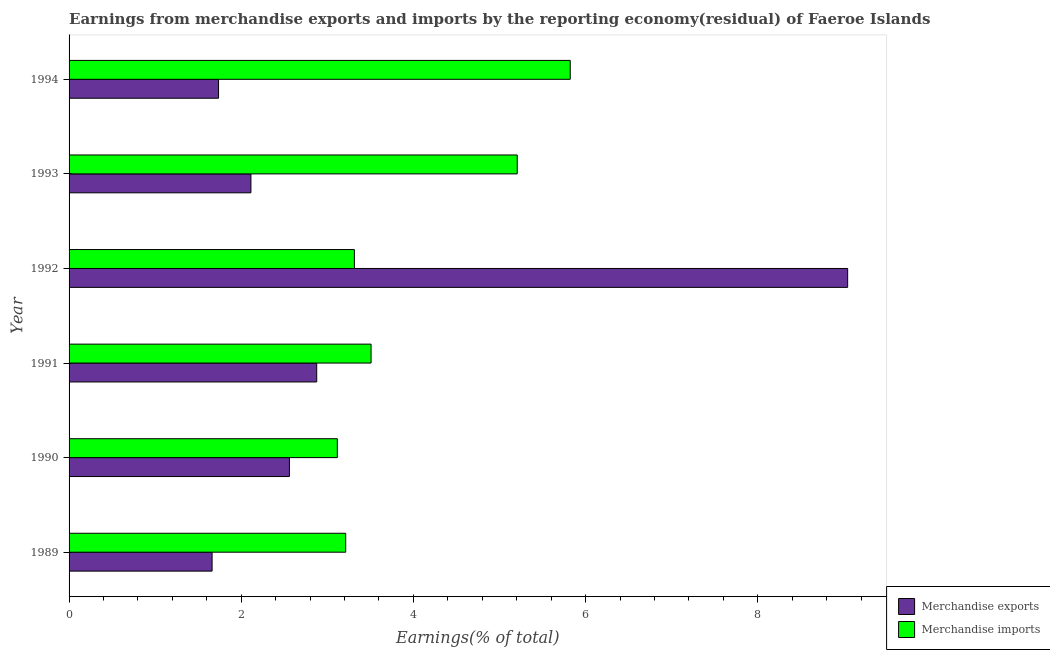How many groups of bars are there?
Offer a terse response. 6. Are the number of bars per tick equal to the number of legend labels?
Provide a short and direct response. Yes. How many bars are there on the 5th tick from the bottom?
Your answer should be very brief. 2. What is the label of the 4th group of bars from the top?
Offer a terse response. 1991. In how many cases, is the number of bars for a given year not equal to the number of legend labels?
Give a very brief answer. 0. What is the earnings from merchandise imports in 1990?
Your answer should be very brief. 3.12. Across all years, what is the maximum earnings from merchandise imports?
Give a very brief answer. 5.82. Across all years, what is the minimum earnings from merchandise imports?
Give a very brief answer. 3.12. In which year was the earnings from merchandise exports minimum?
Keep it short and to the point. 1989. What is the total earnings from merchandise exports in the graph?
Offer a terse response. 19.99. What is the difference between the earnings from merchandise exports in 1992 and that in 1993?
Make the answer very short. 6.93. What is the difference between the earnings from merchandise imports in 1992 and the earnings from merchandise exports in 1991?
Offer a very short reply. 0.44. What is the average earnings from merchandise imports per year?
Your answer should be very brief. 4.03. In the year 1991, what is the difference between the earnings from merchandise imports and earnings from merchandise exports?
Offer a very short reply. 0.63. In how many years, is the earnings from merchandise imports greater than 2.4 %?
Provide a short and direct response. 6. What is the ratio of the earnings from merchandise exports in 1989 to that in 1994?
Your answer should be very brief. 0.96. Is the earnings from merchandise exports in 1990 less than that in 1992?
Provide a succinct answer. Yes. Is the difference between the earnings from merchandise exports in 1990 and 1992 greater than the difference between the earnings from merchandise imports in 1990 and 1992?
Ensure brevity in your answer.  No. What is the difference between the highest and the second highest earnings from merchandise imports?
Offer a very short reply. 0.62. What is the difference between the highest and the lowest earnings from merchandise exports?
Offer a terse response. 7.38. In how many years, is the earnings from merchandise imports greater than the average earnings from merchandise imports taken over all years?
Offer a very short reply. 2. What does the 2nd bar from the top in 1991 represents?
Keep it short and to the point. Merchandise exports. What does the 1st bar from the bottom in 1994 represents?
Make the answer very short. Merchandise exports. Are all the bars in the graph horizontal?
Your response must be concise. Yes. How many years are there in the graph?
Keep it short and to the point. 6. What is the difference between two consecutive major ticks on the X-axis?
Your answer should be compact. 2. Are the values on the major ticks of X-axis written in scientific E-notation?
Your answer should be compact. No. Does the graph contain any zero values?
Make the answer very short. No. What is the title of the graph?
Your response must be concise. Earnings from merchandise exports and imports by the reporting economy(residual) of Faeroe Islands. Does "National Visitors" appear as one of the legend labels in the graph?
Provide a short and direct response. No. What is the label or title of the X-axis?
Give a very brief answer. Earnings(% of total). What is the Earnings(% of total) in Merchandise exports in 1989?
Ensure brevity in your answer.  1.66. What is the Earnings(% of total) in Merchandise imports in 1989?
Make the answer very short. 3.21. What is the Earnings(% of total) in Merchandise exports in 1990?
Provide a succinct answer. 2.56. What is the Earnings(% of total) of Merchandise imports in 1990?
Your response must be concise. 3.12. What is the Earnings(% of total) in Merchandise exports in 1991?
Your response must be concise. 2.88. What is the Earnings(% of total) in Merchandise imports in 1991?
Keep it short and to the point. 3.51. What is the Earnings(% of total) of Merchandise exports in 1992?
Make the answer very short. 9.04. What is the Earnings(% of total) in Merchandise imports in 1992?
Provide a succinct answer. 3.31. What is the Earnings(% of total) of Merchandise exports in 1993?
Keep it short and to the point. 2.11. What is the Earnings(% of total) in Merchandise imports in 1993?
Ensure brevity in your answer.  5.21. What is the Earnings(% of total) of Merchandise exports in 1994?
Keep it short and to the point. 1.74. What is the Earnings(% of total) of Merchandise imports in 1994?
Offer a terse response. 5.82. Across all years, what is the maximum Earnings(% of total) of Merchandise exports?
Provide a short and direct response. 9.04. Across all years, what is the maximum Earnings(% of total) of Merchandise imports?
Provide a succinct answer. 5.82. Across all years, what is the minimum Earnings(% of total) of Merchandise exports?
Keep it short and to the point. 1.66. Across all years, what is the minimum Earnings(% of total) of Merchandise imports?
Your response must be concise. 3.12. What is the total Earnings(% of total) of Merchandise exports in the graph?
Provide a short and direct response. 19.99. What is the total Earnings(% of total) of Merchandise imports in the graph?
Give a very brief answer. 24.18. What is the difference between the Earnings(% of total) in Merchandise exports in 1989 and that in 1990?
Give a very brief answer. -0.9. What is the difference between the Earnings(% of total) of Merchandise imports in 1989 and that in 1990?
Keep it short and to the point. 0.1. What is the difference between the Earnings(% of total) of Merchandise exports in 1989 and that in 1991?
Give a very brief answer. -1.22. What is the difference between the Earnings(% of total) of Merchandise imports in 1989 and that in 1991?
Your answer should be compact. -0.29. What is the difference between the Earnings(% of total) in Merchandise exports in 1989 and that in 1992?
Give a very brief answer. -7.38. What is the difference between the Earnings(% of total) in Merchandise imports in 1989 and that in 1992?
Your answer should be very brief. -0.1. What is the difference between the Earnings(% of total) of Merchandise exports in 1989 and that in 1993?
Make the answer very short. -0.45. What is the difference between the Earnings(% of total) in Merchandise imports in 1989 and that in 1993?
Provide a succinct answer. -1.99. What is the difference between the Earnings(% of total) of Merchandise exports in 1989 and that in 1994?
Your answer should be very brief. -0.07. What is the difference between the Earnings(% of total) of Merchandise imports in 1989 and that in 1994?
Provide a short and direct response. -2.61. What is the difference between the Earnings(% of total) of Merchandise exports in 1990 and that in 1991?
Offer a very short reply. -0.32. What is the difference between the Earnings(% of total) of Merchandise imports in 1990 and that in 1991?
Offer a terse response. -0.39. What is the difference between the Earnings(% of total) in Merchandise exports in 1990 and that in 1992?
Provide a succinct answer. -6.48. What is the difference between the Earnings(% of total) in Merchandise imports in 1990 and that in 1992?
Provide a short and direct response. -0.2. What is the difference between the Earnings(% of total) in Merchandise exports in 1990 and that in 1993?
Your answer should be compact. 0.45. What is the difference between the Earnings(% of total) of Merchandise imports in 1990 and that in 1993?
Ensure brevity in your answer.  -2.09. What is the difference between the Earnings(% of total) in Merchandise exports in 1990 and that in 1994?
Give a very brief answer. 0.82. What is the difference between the Earnings(% of total) in Merchandise imports in 1990 and that in 1994?
Provide a short and direct response. -2.71. What is the difference between the Earnings(% of total) of Merchandise exports in 1991 and that in 1992?
Ensure brevity in your answer.  -6.17. What is the difference between the Earnings(% of total) in Merchandise imports in 1991 and that in 1992?
Your response must be concise. 0.19. What is the difference between the Earnings(% of total) of Merchandise exports in 1991 and that in 1993?
Your response must be concise. 0.76. What is the difference between the Earnings(% of total) in Merchandise imports in 1991 and that in 1993?
Your answer should be very brief. -1.7. What is the difference between the Earnings(% of total) in Merchandise exports in 1991 and that in 1994?
Keep it short and to the point. 1.14. What is the difference between the Earnings(% of total) of Merchandise imports in 1991 and that in 1994?
Your answer should be very brief. -2.31. What is the difference between the Earnings(% of total) of Merchandise exports in 1992 and that in 1993?
Your answer should be compact. 6.93. What is the difference between the Earnings(% of total) of Merchandise imports in 1992 and that in 1993?
Make the answer very short. -1.89. What is the difference between the Earnings(% of total) in Merchandise exports in 1992 and that in 1994?
Give a very brief answer. 7.31. What is the difference between the Earnings(% of total) of Merchandise imports in 1992 and that in 1994?
Offer a terse response. -2.51. What is the difference between the Earnings(% of total) of Merchandise exports in 1993 and that in 1994?
Ensure brevity in your answer.  0.38. What is the difference between the Earnings(% of total) in Merchandise imports in 1993 and that in 1994?
Make the answer very short. -0.62. What is the difference between the Earnings(% of total) in Merchandise exports in 1989 and the Earnings(% of total) in Merchandise imports in 1990?
Your answer should be compact. -1.45. What is the difference between the Earnings(% of total) in Merchandise exports in 1989 and the Earnings(% of total) in Merchandise imports in 1991?
Your answer should be very brief. -1.85. What is the difference between the Earnings(% of total) in Merchandise exports in 1989 and the Earnings(% of total) in Merchandise imports in 1992?
Offer a very short reply. -1.65. What is the difference between the Earnings(% of total) in Merchandise exports in 1989 and the Earnings(% of total) in Merchandise imports in 1993?
Your response must be concise. -3.54. What is the difference between the Earnings(% of total) of Merchandise exports in 1989 and the Earnings(% of total) of Merchandise imports in 1994?
Your response must be concise. -4.16. What is the difference between the Earnings(% of total) in Merchandise exports in 1990 and the Earnings(% of total) in Merchandise imports in 1991?
Your answer should be very brief. -0.95. What is the difference between the Earnings(% of total) in Merchandise exports in 1990 and the Earnings(% of total) in Merchandise imports in 1992?
Ensure brevity in your answer.  -0.75. What is the difference between the Earnings(% of total) of Merchandise exports in 1990 and the Earnings(% of total) of Merchandise imports in 1993?
Give a very brief answer. -2.65. What is the difference between the Earnings(% of total) in Merchandise exports in 1990 and the Earnings(% of total) in Merchandise imports in 1994?
Your answer should be very brief. -3.26. What is the difference between the Earnings(% of total) of Merchandise exports in 1991 and the Earnings(% of total) of Merchandise imports in 1992?
Give a very brief answer. -0.44. What is the difference between the Earnings(% of total) in Merchandise exports in 1991 and the Earnings(% of total) in Merchandise imports in 1993?
Your response must be concise. -2.33. What is the difference between the Earnings(% of total) in Merchandise exports in 1991 and the Earnings(% of total) in Merchandise imports in 1994?
Offer a terse response. -2.94. What is the difference between the Earnings(% of total) in Merchandise exports in 1992 and the Earnings(% of total) in Merchandise imports in 1993?
Provide a short and direct response. 3.84. What is the difference between the Earnings(% of total) in Merchandise exports in 1992 and the Earnings(% of total) in Merchandise imports in 1994?
Ensure brevity in your answer.  3.22. What is the difference between the Earnings(% of total) in Merchandise exports in 1993 and the Earnings(% of total) in Merchandise imports in 1994?
Make the answer very short. -3.71. What is the average Earnings(% of total) of Merchandise exports per year?
Provide a short and direct response. 3.33. What is the average Earnings(% of total) in Merchandise imports per year?
Your answer should be compact. 4.03. In the year 1989, what is the difference between the Earnings(% of total) of Merchandise exports and Earnings(% of total) of Merchandise imports?
Give a very brief answer. -1.55. In the year 1990, what is the difference between the Earnings(% of total) of Merchandise exports and Earnings(% of total) of Merchandise imports?
Keep it short and to the point. -0.56. In the year 1991, what is the difference between the Earnings(% of total) of Merchandise exports and Earnings(% of total) of Merchandise imports?
Offer a terse response. -0.63. In the year 1992, what is the difference between the Earnings(% of total) of Merchandise exports and Earnings(% of total) of Merchandise imports?
Keep it short and to the point. 5.73. In the year 1993, what is the difference between the Earnings(% of total) of Merchandise exports and Earnings(% of total) of Merchandise imports?
Your response must be concise. -3.09. In the year 1994, what is the difference between the Earnings(% of total) of Merchandise exports and Earnings(% of total) of Merchandise imports?
Your answer should be compact. -4.09. What is the ratio of the Earnings(% of total) of Merchandise exports in 1989 to that in 1990?
Your response must be concise. 0.65. What is the ratio of the Earnings(% of total) of Merchandise imports in 1989 to that in 1990?
Provide a succinct answer. 1.03. What is the ratio of the Earnings(% of total) of Merchandise exports in 1989 to that in 1991?
Give a very brief answer. 0.58. What is the ratio of the Earnings(% of total) in Merchandise imports in 1989 to that in 1991?
Provide a short and direct response. 0.92. What is the ratio of the Earnings(% of total) of Merchandise exports in 1989 to that in 1992?
Offer a very short reply. 0.18. What is the ratio of the Earnings(% of total) of Merchandise imports in 1989 to that in 1992?
Offer a very short reply. 0.97. What is the ratio of the Earnings(% of total) in Merchandise exports in 1989 to that in 1993?
Offer a terse response. 0.79. What is the ratio of the Earnings(% of total) in Merchandise imports in 1989 to that in 1993?
Your response must be concise. 0.62. What is the ratio of the Earnings(% of total) of Merchandise exports in 1989 to that in 1994?
Your answer should be compact. 0.96. What is the ratio of the Earnings(% of total) in Merchandise imports in 1989 to that in 1994?
Provide a succinct answer. 0.55. What is the ratio of the Earnings(% of total) of Merchandise exports in 1990 to that in 1991?
Keep it short and to the point. 0.89. What is the ratio of the Earnings(% of total) of Merchandise imports in 1990 to that in 1991?
Your answer should be very brief. 0.89. What is the ratio of the Earnings(% of total) of Merchandise exports in 1990 to that in 1992?
Your answer should be very brief. 0.28. What is the ratio of the Earnings(% of total) of Merchandise imports in 1990 to that in 1992?
Offer a terse response. 0.94. What is the ratio of the Earnings(% of total) of Merchandise exports in 1990 to that in 1993?
Provide a succinct answer. 1.21. What is the ratio of the Earnings(% of total) in Merchandise imports in 1990 to that in 1993?
Make the answer very short. 0.6. What is the ratio of the Earnings(% of total) in Merchandise exports in 1990 to that in 1994?
Your answer should be very brief. 1.47. What is the ratio of the Earnings(% of total) in Merchandise imports in 1990 to that in 1994?
Your answer should be very brief. 0.54. What is the ratio of the Earnings(% of total) of Merchandise exports in 1991 to that in 1992?
Your answer should be compact. 0.32. What is the ratio of the Earnings(% of total) in Merchandise imports in 1991 to that in 1992?
Offer a very short reply. 1.06. What is the ratio of the Earnings(% of total) in Merchandise exports in 1991 to that in 1993?
Your answer should be compact. 1.36. What is the ratio of the Earnings(% of total) in Merchandise imports in 1991 to that in 1993?
Offer a terse response. 0.67. What is the ratio of the Earnings(% of total) of Merchandise exports in 1991 to that in 1994?
Your response must be concise. 1.66. What is the ratio of the Earnings(% of total) of Merchandise imports in 1991 to that in 1994?
Make the answer very short. 0.6. What is the ratio of the Earnings(% of total) in Merchandise exports in 1992 to that in 1993?
Keep it short and to the point. 4.28. What is the ratio of the Earnings(% of total) of Merchandise imports in 1992 to that in 1993?
Give a very brief answer. 0.64. What is the ratio of the Earnings(% of total) in Merchandise exports in 1992 to that in 1994?
Provide a succinct answer. 5.21. What is the ratio of the Earnings(% of total) of Merchandise imports in 1992 to that in 1994?
Make the answer very short. 0.57. What is the ratio of the Earnings(% of total) of Merchandise exports in 1993 to that in 1994?
Give a very brief answer. 1.22. What is the ratio of the Earnings(% of total) of Merchandise imports in 1993 to that in 1994?
Your response must be concise. 0.89. What is the difference between the highest and the second highest Earnings(% of total) in Merchandise exports?
Give a very brief answer. 6.17. What is the difference between the highest and the second highest Earnings(% of total) of Merchandise imports?
Offer a very short reply. 0.62. What is the difference between the highest and the lowest Earnings(% of total) in Merchandise exports?
Your answer should be very brief. 7.38. What is the difference between the highest and the lowest Earnings(% of total) in Merchandise imports?
Your answer should be very brief. 2.71. 